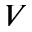<formula> <loc_0><loc_0><loc_500><loc_500>V</formula> 